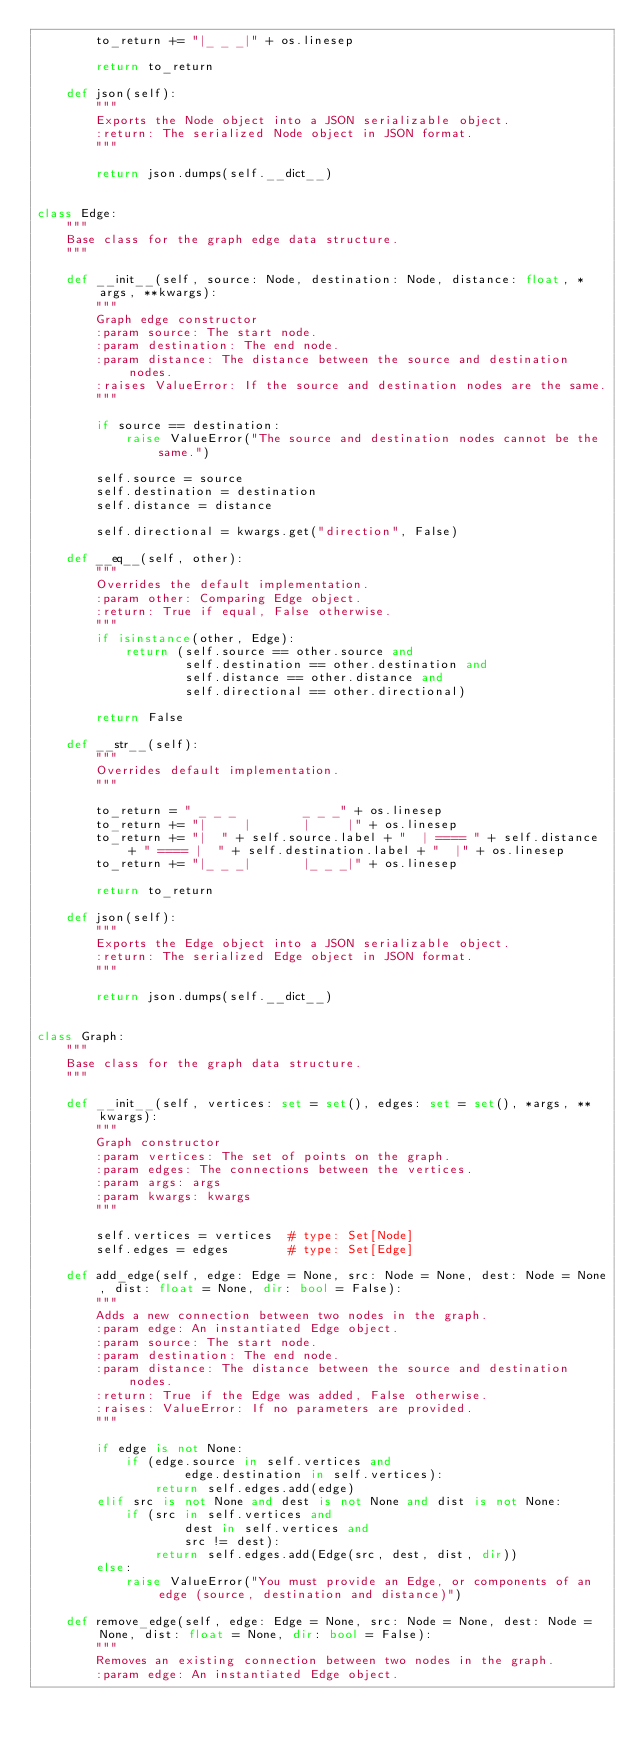<code> <loc_0><loc_0><loc_500><loc_500><_Python_>        to_return += "|_ _ _|" + os.linesep

        return to_return

    def json(self):
        """
        Exports the Node object into a JSON serializable object.
        :return: The serialized Node object in JSON format.
        """

        return json.dumps(self.__dict__)


class Edge:
    """
    Base class for the graph edge data structure.
    """

    def __init__(self, source: Node, destination: Node, distance: float, *args, **kwargs):
        """
        Graph edge constructor
        :param source: The start node.
        :param destination: The end node.
        :param distance: The distance between the source and destination nodes.
        :raises ValueError: If the source and destination nodes are the same.
        """

        if source == destination:
            raise ValueError("The source and destination nodes cannot be the same.")

        self.source = source
        self.destination = destination
        self.distance = distance

        self.directional = kwargs.get("direction", False)

    def __eq__(self, other):
        """
        Overrides the default implementation.
        :param other: Comparing Edge object.
        :return: True if equal, False otherwise.
        """
        if isinstance(other, Edge):
            return (self.source == other.source and
                    self.destination == other.destination and
                    self.distance == other.distance and
                    self.directional == other.directional)

        return False

    def __str__(self):
        """
        Overrides default implementation.
        """

        to_return = " _ _ _         _ _ _" + os.linesep
        to_return += "|     |       |     |" + os.linesep
        to_return += "|  " + self.source.label + "  | ==== " + self.distance + " ==== |  " + self.destination.label + "  |" + os.linesep
        to_return += "|_ _ _|       |_ _ _|" + os.linesep

        return to_return

    def json(self):
        """
        Exports the Edge object into a JSON serializable object.
        :return: The serialized Edge object in JSON format.
        """

        return json.dumps(self.__dict__)


class Graph:
    """
    Base class for the graph data structure.
    """

    def __init__(self, vertices: set = set(), edges: set = set(), *args, **kwargs):
        """
        Graph constructor
        :param vertices: The set of points on the graph.
        :param edges: The connections between the vertices.
        :param args: args
        :param kwargs: kwargs
        """

        self.vertices = vertices  # type: Set[Node]
        self.edges = edges        # type: Set[Edge]

    def add_edge(self, edge: Edge = None, src: Node = None, dest: Node = None, dist: float = None, dir: bool = False):
        """
        Adds a new connection between two nodes in the graph.
        :param edge: An instantiated Edge object.
        :param source: The start node.
        :param destination: The end node.
        :param distance: The distance between the source and destination nodes.
        :return: True if the Edge was added, False otherwise.
        :raises: ValueError: If no parameters are provided.
        """

        if edge is not None:
            if (edge.source in self.vertices and
                    edge.destination in self.vertices):
                return self.edges.add(edge)
        elif src is not None and dest is not None and dist is not None:
            if (src in self.vertices and
                    dest in self.vertices and
                    src != dest):
                return self.edges.add(Edge(src, dest, dist, dir))
        else:
            raise ValueError("You must provide an Edge, or components of an edge (source, destination and distance)")

    def remove_edge(self, edge: Edge = None, src: Node = None, dest: Node = None, dist: float = None, dir: bool = False):
        """
        Removes an existing connection between two nodes in the graph.
        :param edge: An instantiated Edge object.</code> 